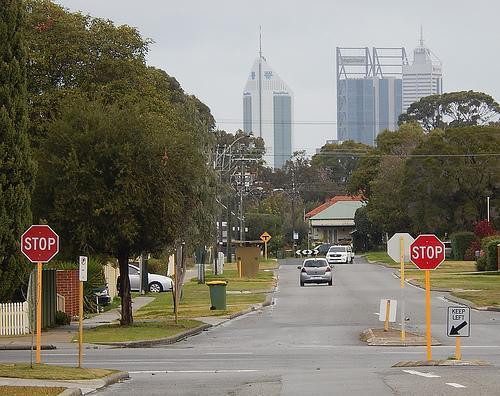How many stop signs are pictured?
Give a very brief answer. 2. 